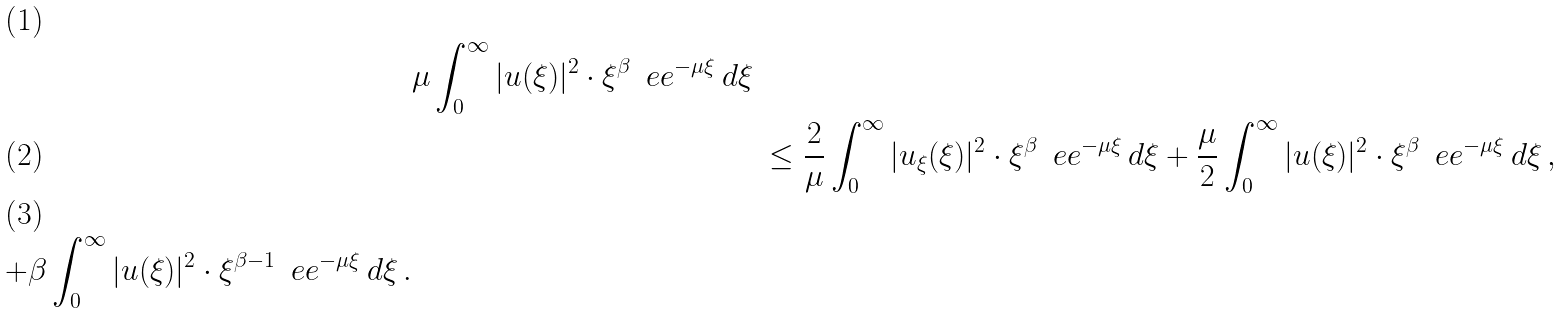Convert formula to latex. <formula><loc_0><loc_0><loc_500><loc_500>& \mu \int _ { 0 } ^ { \infty } | u ( \xi ) | ^ { 2 } \cdot \xi ^ { \beta } \, \ e e ^ { - \mu \xi } \, d \xi \\ & & \leq \frac { 2 } { \mu } \int _ { 0 } ^ { \infty } | u _ { \xi } ( \xi ) | ^ { 2 } \cdot \xi ^ { \beta } \, \ e e ^ { - \mu \xi } \, d \xi + \frac { \mu } { 2 } \int _ { 0 } ^ { \infty } | u ( \xi ) | ^ { 2 } \cdot \xi ^ { \beta } \, \ e e ^ { - \mu \xi } \, d \xi \, , \\ + \beta \int _ { 0 } ^ { \infty } | u ( \xi ) | ^ { 2 } \cdot \xi ^ { \beta - 1 } \, \ e e ^ { - \mu \xi } \, d \xi \, .</formula> 